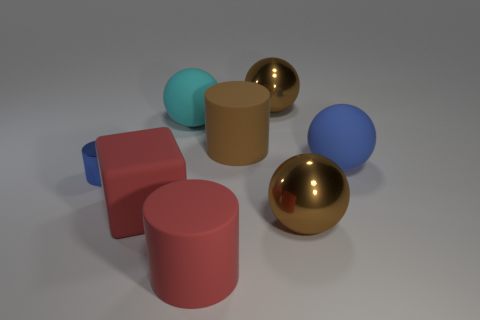What number of large matte cylinders have the same color as the matte block?
Keep it short and to the point. 1. There is a brown metallic ball in front of the big brown metal object on the left side of the large brown metallic sphere that is in front of the cyan rubber ball; what is its size?
Provide a succinct answer. Large. Does the large ball that is on the left side of the big red matte cylinder have the same material as the small cylinder?
Give a very brief answer. No. What number of objects are either large cyan matte things or blue matte things?
Your answer should be very brief. 2. What size is the cyan object that is the same shape as the big blue rubber object?
Provide a short and direct response. Large. Is there any other thing that has the same size as the blue cylinder?
Your response must be concise. No. How many other objects are there of the same color as the metal cylinder?
Keep it short and to the point. 1. How many cubes are either yellow rubber objects or large cyan objects?
Offer a very short reply. 0. There is a sphere to the left of the large metallic object behind the blue rubber thing; what is its color?
Your answer should be compact. Cyan. The tiny blue shiny thing is what shape?
Offer a very short reply. Cylinder. 